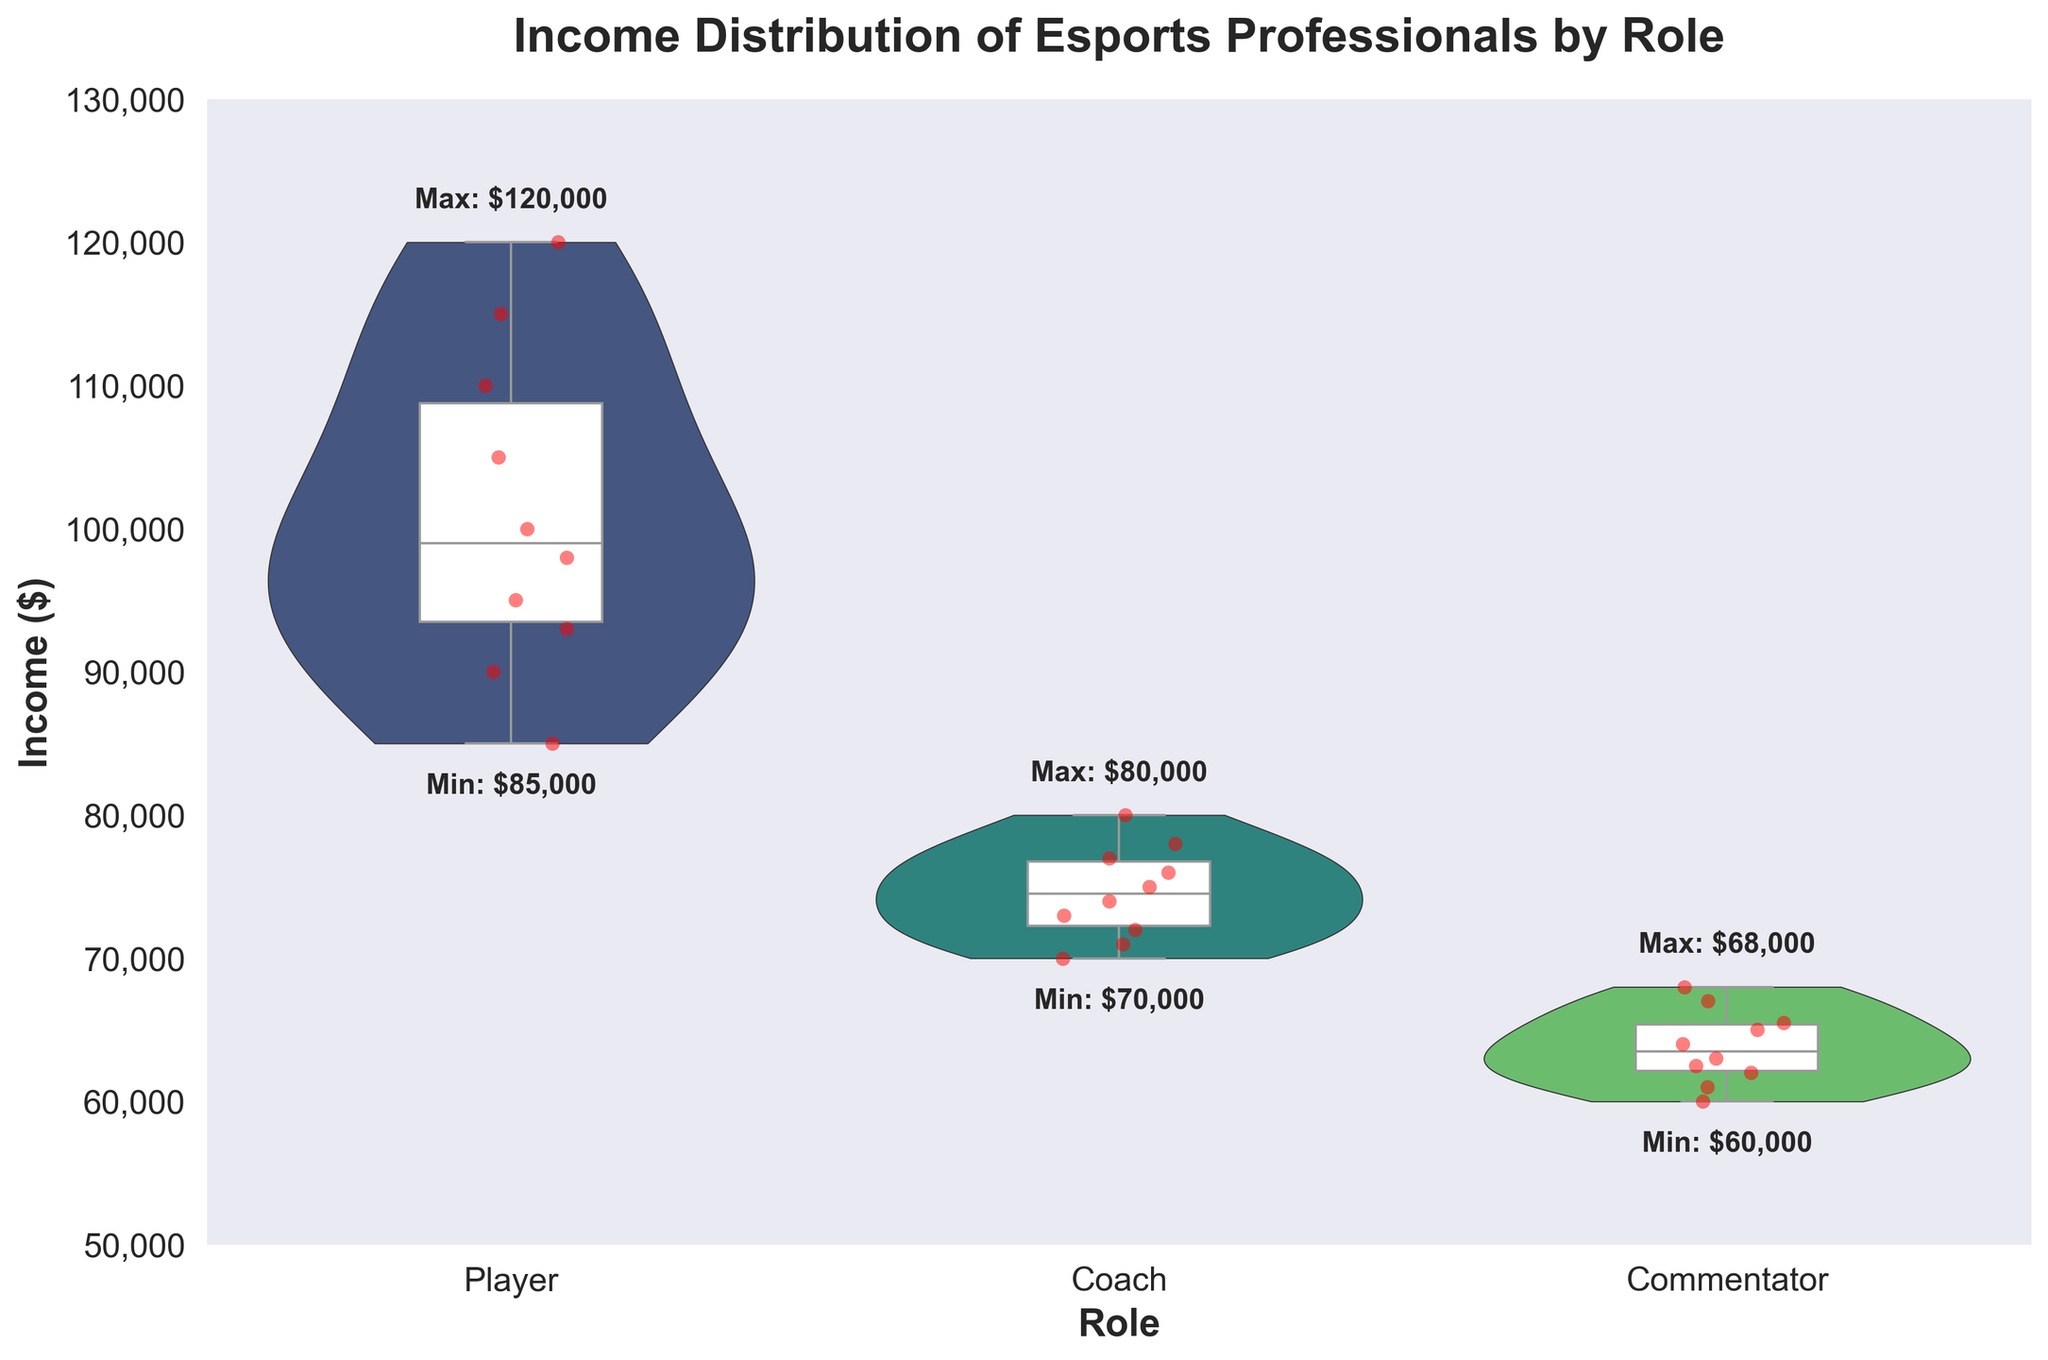What is the title of the figure? The title of the figure is written at the top of the chart.
Answer: Income Distribution of Esports Professionals by Role Which role has the highest income range? The role with the highest income range can be identified by looking at the vertical span of the violin plot and the associated box plot whiskers.
Answer: Player What is the median income for Coaches? The median income for Coaches can be found by identifying the central line within the box plot for the Coach role.
Answer: $75,000 How does the income distribution for Commentators compare to Players? By analyzing the shape and spread of the violin plots and the positions of box plots, we can compare the overall distribution and central tendency. Commentators have a lower and more compressed income range compared to Players.
Answer: Commentators have a lower and narrower distribution Which role has the narrowest income distribution? The role with the narrowest income distribution can be identified by observing the width of the violin plots along the y-axis; the narrower the plot, the less spread out the incomes.
Answer: Commentator What is the maximum income for Players? The maximum income for Players can be seen as the top-most point of the red data points and the whiskers of the box plot for the Player role.
Answer: $120,000 How much lower is the minimum income for Commentators compared to Coaches? To find the difference, subtract the minimum income of Commentators from the minimum income of Coaches, which are indicated by the bottom points of the whiskers.
Answer: $10,000 Between Coaches and Players, whose average income is higher? The average income can be estimated by looking at the center of each box plot. The Player role's box plot is centered at a higher income value compared to that of the Coach role.
Answer: Players How many primary roles are depicted in the figure? The number of primary roles can be identified by counting the distinct categories or violin plots on the x-axis.
Answer: 3 What is the range of incomes for the Coach role? The income range for Coaches is found by subtracting the minimum income from the maximum income within the Coach's distribution.
Answer: $10,000 